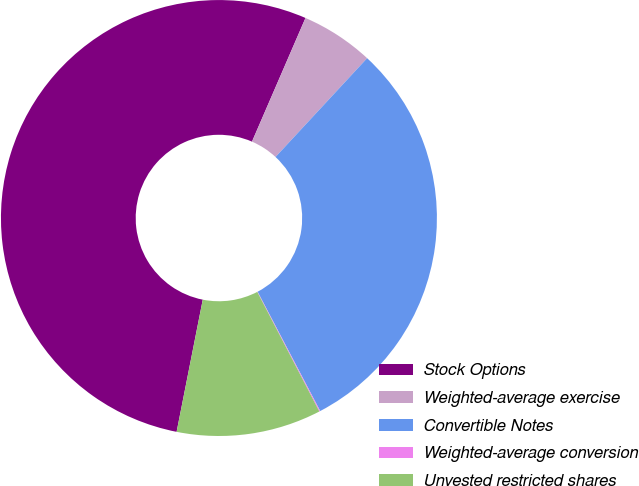Convert chart. <chart><loc_0><loc_0><loc_500><loc_500><pie_chart><fcel>Stock Options<fcel>Weighted-average exercise<fcel>Convertible Notes<fcel>Weighted-average conversion<fcel>Unvested restricted shares<nl><fcel>53.39%<fcel>5.4%<fcel>30.41%<fcel>0.07%<fcel>10.73%<nl></chart> 